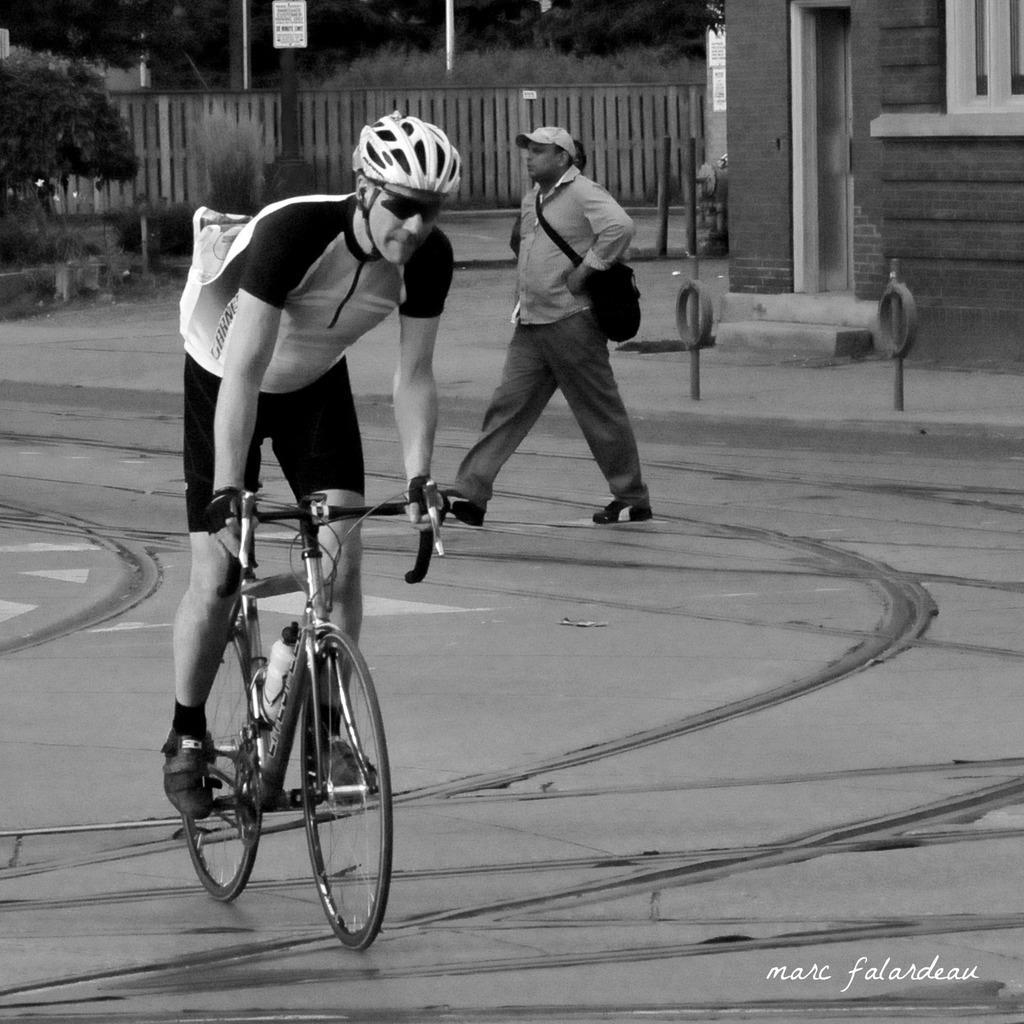Please provide a concise description of this image. The picture is outside of the house. On the right side we have a person. He is walking like slowly. His wearing bag and cap. In the center we have a another person. He's riding a bicycle. He's wearing a helmet. We can see in the background there is a tree and house. 